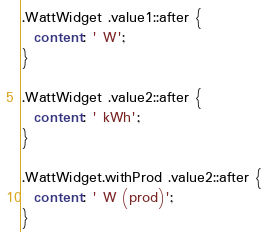Convert code to text. <code><loc_0><loc_0><loc_500><loc_500><_CSS_>.WattWidget .value1::after {
  content: ' W';
}

.WattWidget .value2::after {
  content: ' kWh';
}

.WattWidget.withProd .value2::after {
  content: ' W (prod)';
}
</code> 